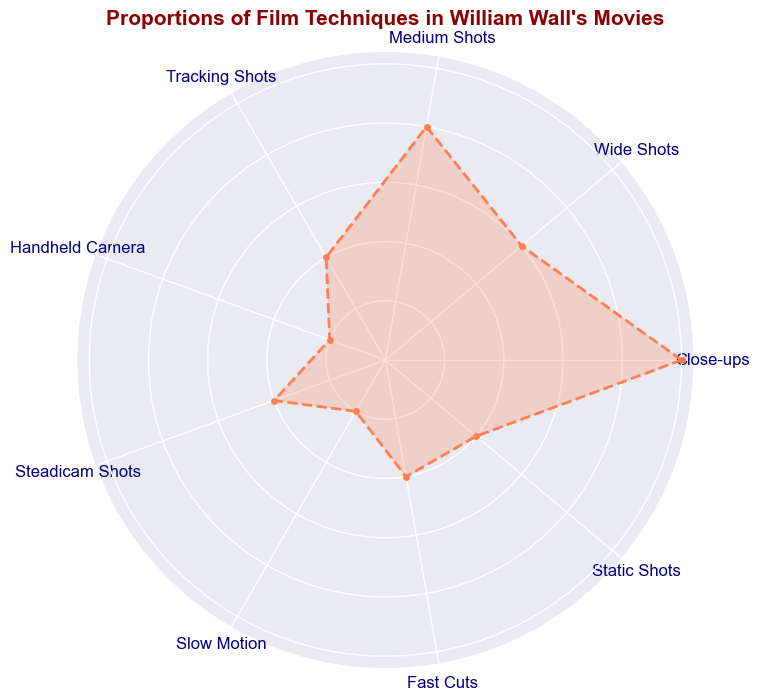What are the three most frequently used film techniques in William Wall's movies? By examining the chart, we see that the highest proportion is for Close-ups (0.25), followed by Medium Shots (0.2), and Wide Shots (0.15)
Answer: Close-ups, Medium Shots, Wide Shots Between Tracking Shots and Static Shots, which technique is used more frequently? From the chart, we can see that the proportion for Tracking Shots is 0.1, and for Static Shots is also 0.1, making them equal in usage
Answer: They are equal What is the combined proportion of Steadicam Shots and Handheld Camera? The proportion for Steadicam Shots is 0.1 and for Handheld Camera is 0.05. Adding these together, we get 0.1 + 0.05 = 0.15
Answer: 0.15 How does the frequency of Fast Cuts compare to Slow Motion? The proportions for both techniques are 0.1 for Fast Cuts and 0.05 for Slow Motion. Fast Cuts are used twice as frequently as Slow Motion
Answer: Fast Cuts are twice as frequent If the total proportion of techniques used sum up to 1, which film technique occupies exactly a quarter of the total usage? The film technique with a proportion of 0.25 is Close-ups, which is exactly a quarter of 1
Answer: Close-ups Which film technique is the least used in William Wall's movies, and what is its proportion? Referring to the chart, the least used techniques are Handheld Camera and Slow Motion, both with a proportion of 0.05
Answer: Handheld Camera and Slow Motion Are medium shots used more frequently than combined Steadicam Shots and Tracking Shots? The proportion for Medium Shots is 0.2, while the combined proportion for Steadicam Shots (0.1) and Tracking Shots (0.1) is 0.2. Thus, Medium Shots and the combined Steadicam Shots and Tracking Shots are used equally
Answer: They are equal 